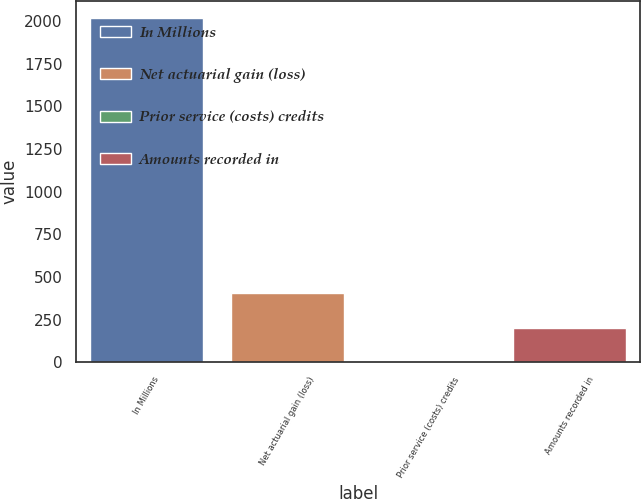<chart> <loc_0><loc_0><loc_500><loc_500><bar_chart><fcel>In Millions<fcel>Net actuarial gain (loss)<fcel>Prior service (costs) credits<fcel>Amounts recorded in<nl><fcel>2018<fcel>403.84<fcel>0.3<fcel>202.07<nl></chart> 